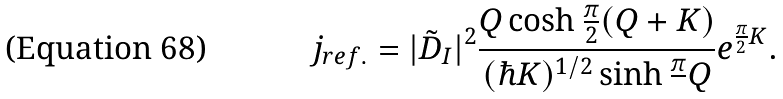Convert formula to latex. <formula><loc_0><loc_0><loc_500><loc_500>j _ { r e f . } = | \tilde { D } _ { I } | ^ { 2 } \frac { Q \cosh \frac { \pi } { 2 } ( Q + K ) } { ( \hbar { K } ) ^ { 1 / 2 } \sinh \frac { \pi } { } Q } e ^ { \frac { \pi } { 2 } K } .</formula> 